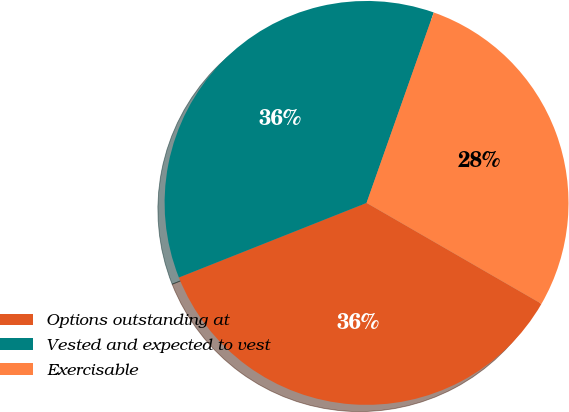Convert chart to OTSL. <chart><loc_0><loc_0><loc_500><loc_500><pie_chart><fcel>Options outstanding at<fcel>Vested and expected to vest<fcel>Exercisable<nl><fcel>35.65%<fcel>36.42%<fcel>27.93%<nl></chart> 